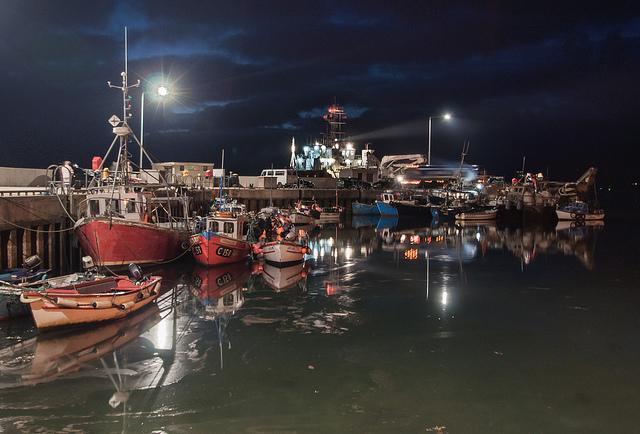What do the small floats on the boats sides here meant to prevent the boats doing?
Answer the question by selecting the correct answer among the 4 following choices.
Options: Getting lost, soaring, bumping, sinking. Bumping. 